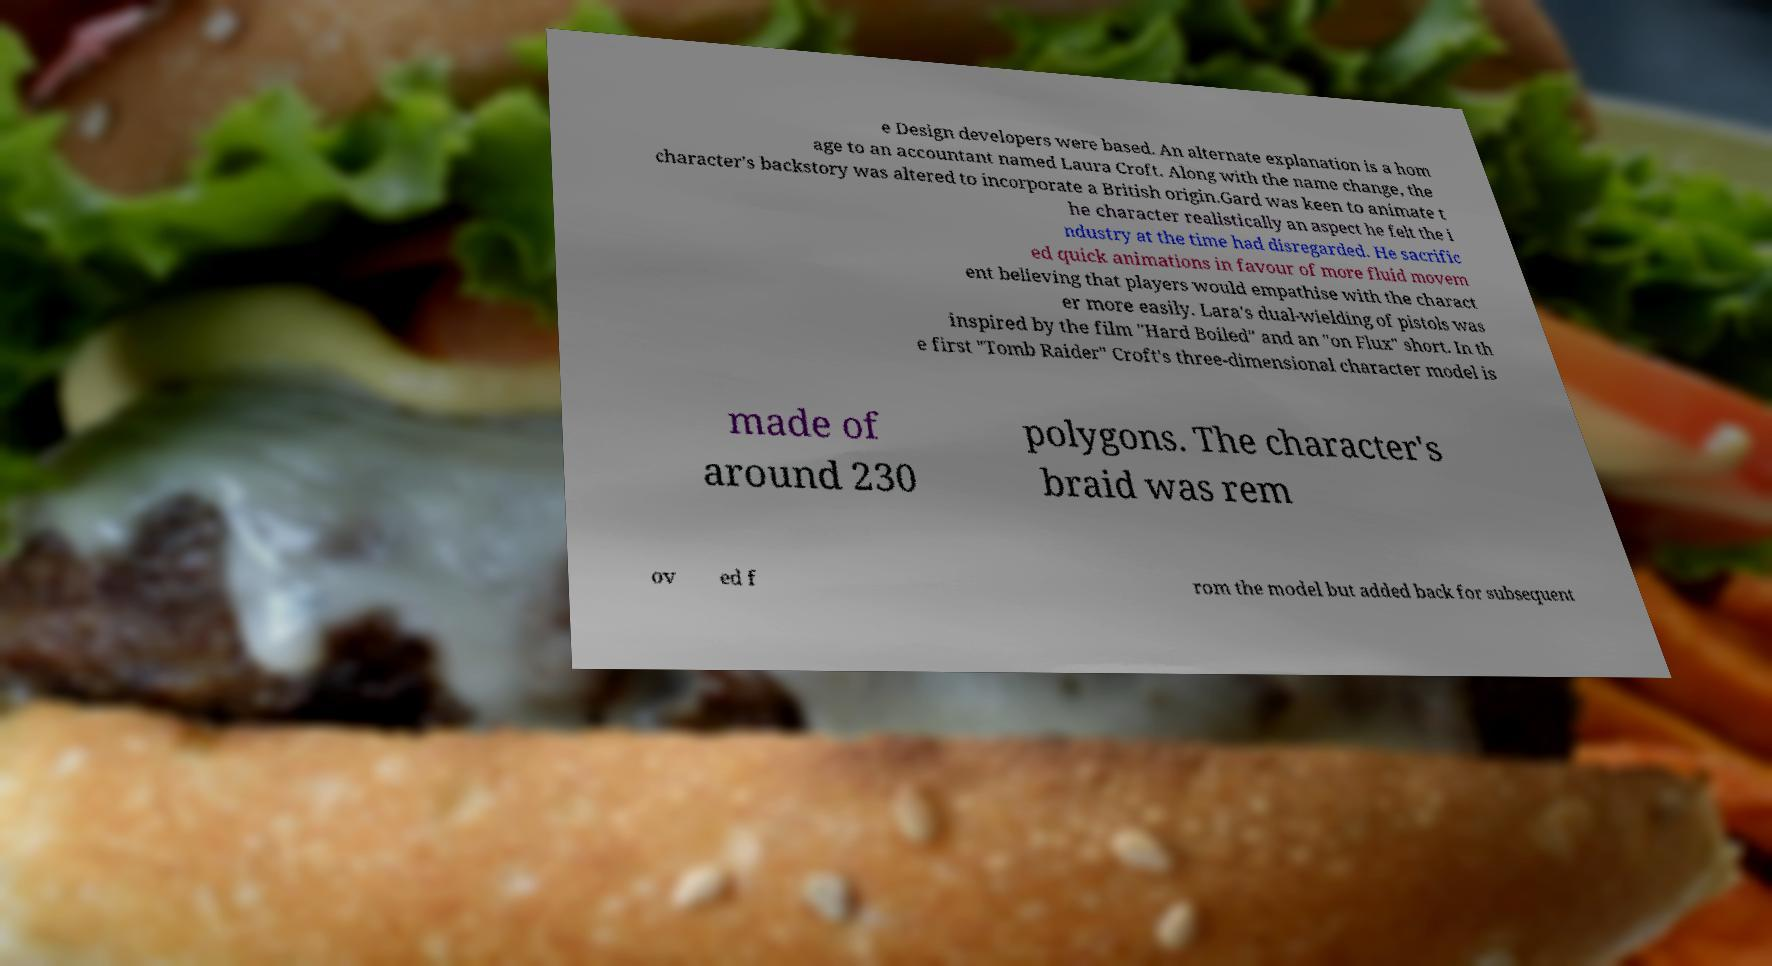For documentation purposes, I need the text within this image transcribed. Could you provide that? e Design developers were based. An alternate explanation is a hom age to an accountant named Laura Croft. Along with the name change, the character's backstory was altered to incorporate a British origin.Gard was keen to animate t he character realistically an aspect he felt the i ndustry at the time had disregarded. He sacrific ed quick animations in favour of more fluid movem ent believing that players would empathise with the charact er more easily. Lara's dual-wielding of pistols was inspired by the film "Hard Boiled" and an "on Flux" short. In th e first "Tomb Raider" Croft's three-dimensional character model is made of around 230 polygons. The character's braid was rem ov ed f rom the model but added back for subsequent 